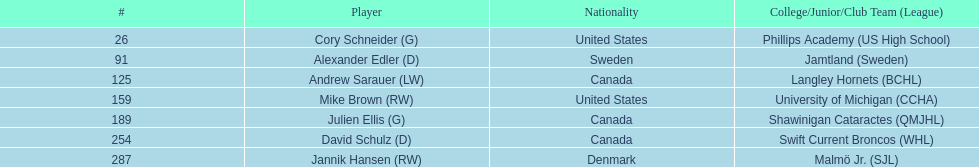Can you give me this table as a dict? {'header': ['#', 'Player', 'Nationality', 'College/Junior/Club Team (League)'], 'rows': [['26', 'Cory Schneider (G)', 'United States', 'Phillips Academy (US High School)'], ['91', 'Alexander Edler (D)', 'Sweden', 'Jamtland (Sweden)'], ['125', 'Andrew Sarauer (LW)', 'Canada', 'Langley Hornets (BCHL)'], ['159', 'Mike Brown (RW)', 'United States', 'University of Michigan (CCHA)'], ['189', 'Julien Ellis (G)', 'Canada', 'Shawinigan Cataractes (QMJHL)'], ['254', 'David Schulz (D)', 'Canada', 'Swift Current Broncos (WHL)'], ['287', 'Jannik Hansen (RW)', 'Denmark', 'Malmö Jr. (SJL)']]} List each player drafted from canada. Andrew Sarauer (LW), Julien Ellis (G), David Schulz (D). 